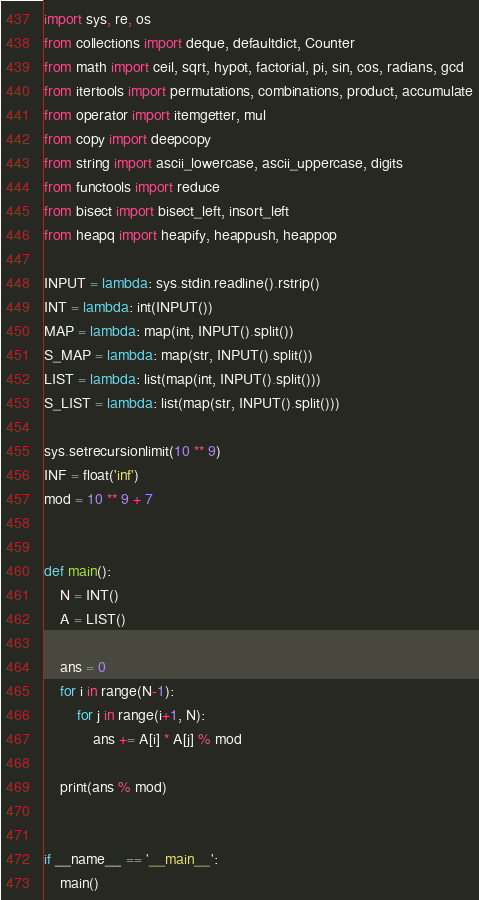Convert code to text. <code><loc_0><loc_0><loc_500><loc_500><_Python_>import sys, re, os
from collections import deque, defaultdict, Counter
from math import ceil, sqrt, hypot, factorial, pi, sin, cos, radians, gcd
from itertools import permutations, combinations, product, accumulate
from operator import itemgetter, mul
from copy import deepcopy
from string import ascii_lowercase, ascii_uppercase, digits
from functools import reduce
from bisect import bisect_left, insort_left
from heapq import heapify, heappush, heappop

INPUT = lambda: sys.stdin.readline().rstrip()
INT = lambda: int(INPUT())
MAP = lambda: map(int, INPUT().split())
S_MAP = lambda: map(str, INPUT().split())
LIST = lambda: list(map(int, INPUT().split()))
S_LIST = lambda: list(map(str, INPUT().split()))

sys.setrecursionlimit(10 ** 9)
INF = float('inf')
mod = 10 ** 9 + 7


def main():
    N = INT()
    A = LIST()

    ans = 0
    for i in range(N-1):
        for j in range(i+1, N):
            ans += A[i] * A[j] % mod

    print(ans % mod)


if __name__ == '__main__':
    main()
</code> 